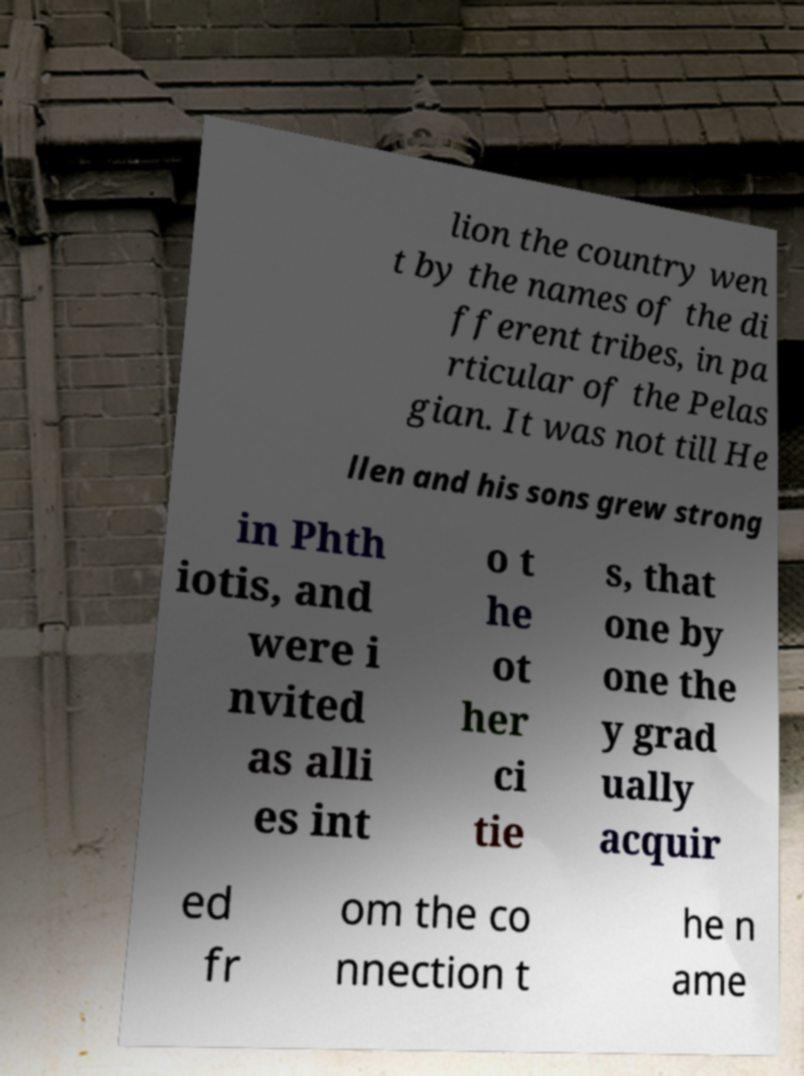Can you read and provide the text displayed in the image?This photo seems to have some interesting text. Can you extract and type it out for me? lion the country wen t by the names of the di fferent tribes, in pa rticular of the Pelas gian. It was not till He llen and his sons grew strong in Phth iotis, and were i nvited as alli es int o t he ot her ci tie s, that one by one the y grad ually acquir ed fr om the co nnection t he n ame 